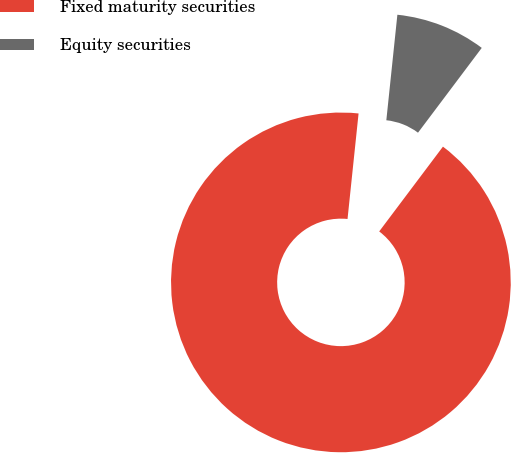Convert chart to OTSL. <chart><loc_0><loc_0><loc_500><loc_500><pie_chart><fcel>Fixed maturity securities<fcel>Equity securities<nl><fcel>91.4%<fcel>8.6%<nl></chart> 